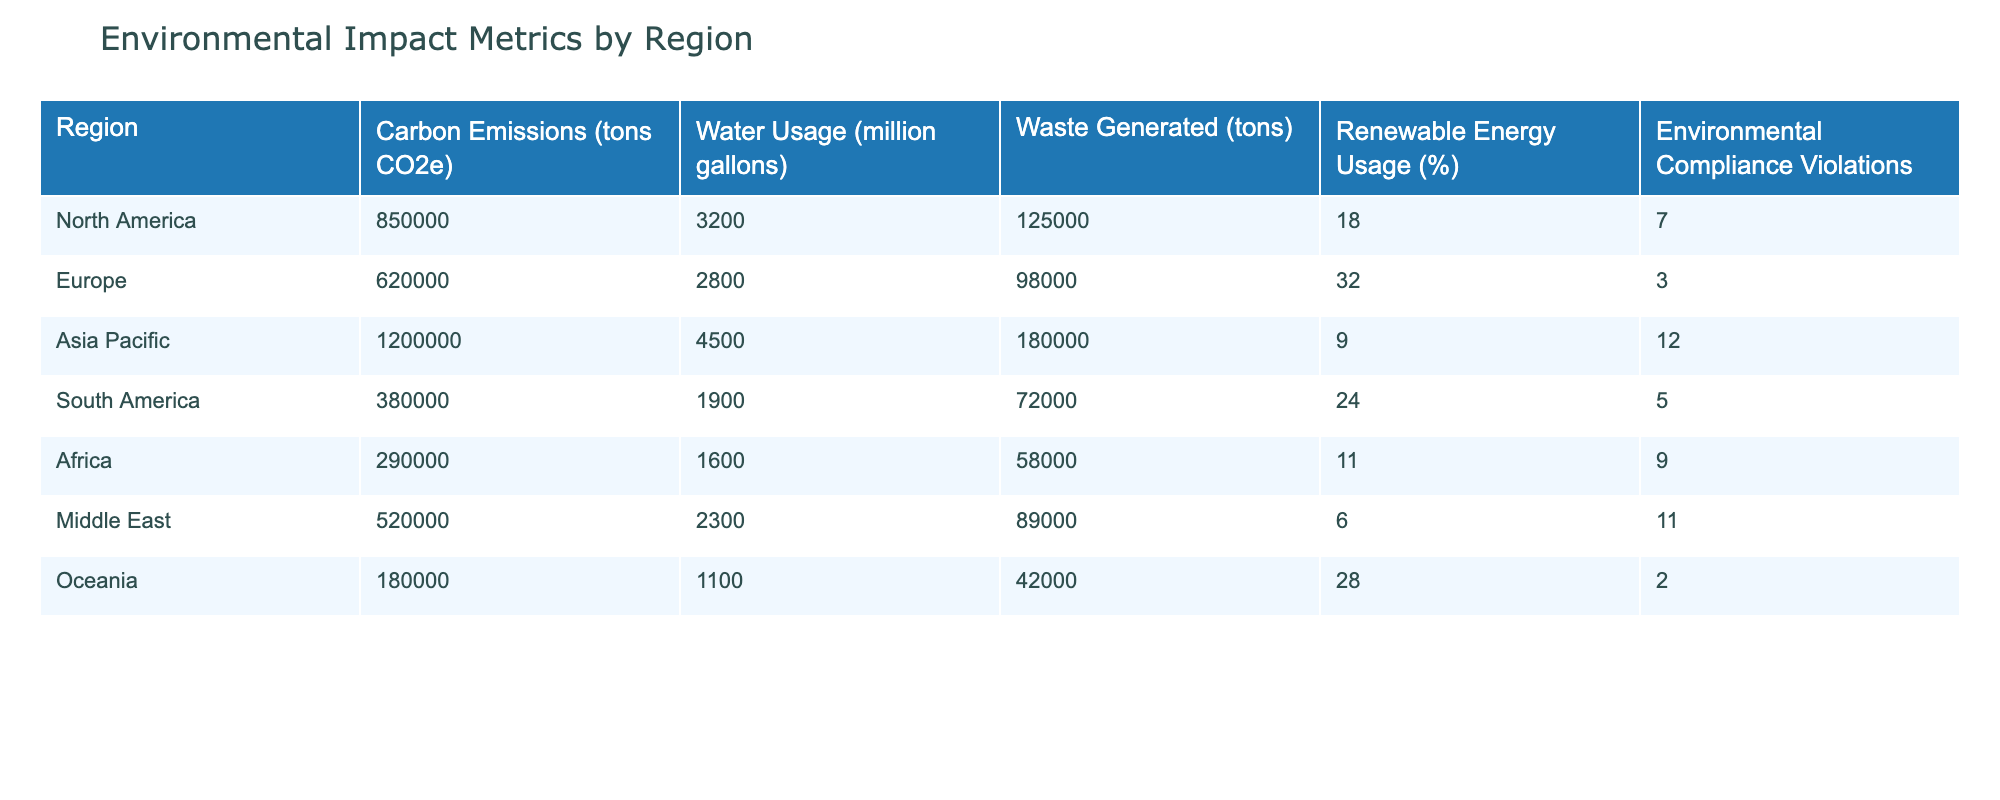What region has the highest carbon emissions? The table shows that Asia Pacific has the highest carbon emissions at 1,200,000 tons CO2e.
Answer: Asia Pacific What is the water usage in Europe? The table lists the water usage in Europe as 2,800 million gallons.
Answer: 2,800 million gallons How much waste is generated in South America? According to the table, South America generates 72,000 tons of waste.
Answer: 72,000 tons Which region has the highest percentage of renewable energy usage? By checking the renewable energy usage percentages in the table, Europe has the highest at 32%.
Answer: Europe What is the average carbon emissions across all regions? First, sum the carbon emissions: 850,000 + 620,000 + 1,200,000 + 380,000 + 290,000 + 520,000 + 180,000 = 3,040,000 tons CO2e. Then, divide by the number of regions (7) to get the average: 3,040,000 / 7 = 434,285.71 tons.
Answer: 434,285.71 tons Which region has the most environmental compliance violations? The table indicates that Asia Pacific has the most compliance violations, with a total of 12.
Answer: Asia Pacific Is renewable energy usage in the Middle East greater than in Africa? The Middle East has 6% renewable energy usage while Africa has 11%, thus the statement is false.
Answer: No What is the total waste generated by regions with renewable energy usage greater than 20%? The regions with more than 20% renewable energy usage are Europe (98,000 tons), South America (72,000 tons), and Oceania (42,000 tons). The total waste generated is 98,000 + 72,000 + 42,000 = 212,000 tons.
Answer: 212,000 tons In which region is water usage the lowest, and what is that usage? By comparing the water usage values, Africa has the lowest water usage of 1,600 million gallons.
Answer: Africa, 1,600 million gallons If we consider only North America and Europe, what is the difference in waste generated between the two? North America generates 125,000 tons of waste, while Europe generates 98,000 tons. The difference is 125,000 - 98,000 = 27,000 tons.
Answer: 27,000 tons 